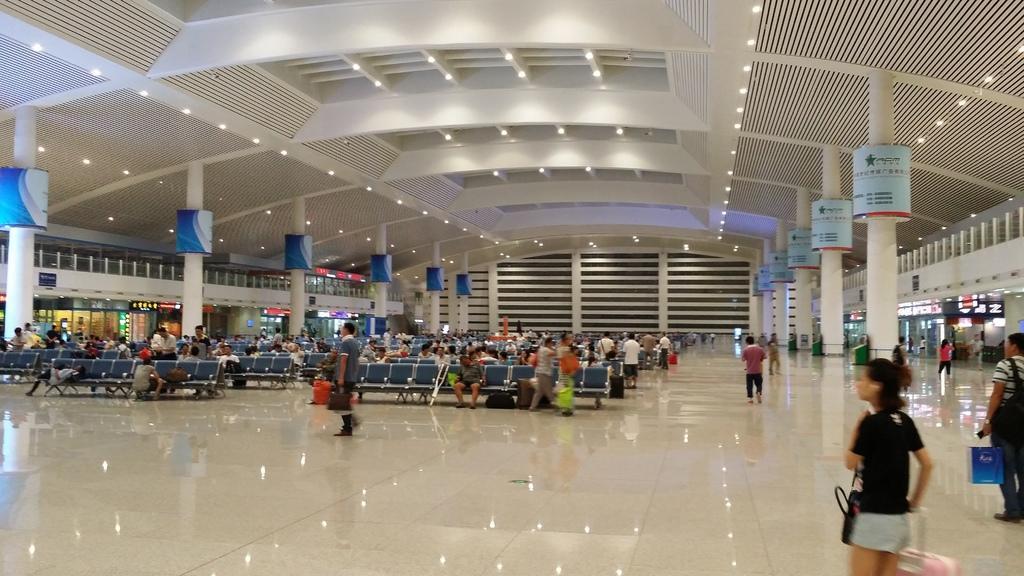Can you describe this image briefly? This picture is clicked inside the hall. In the center we can see the group of persons sitting on the chairs and we can see the group of persons and we can see the pillars and boards on which we can see the text. At the top there is a roof, ceiling lights and we can see the chairs and many other objects. 